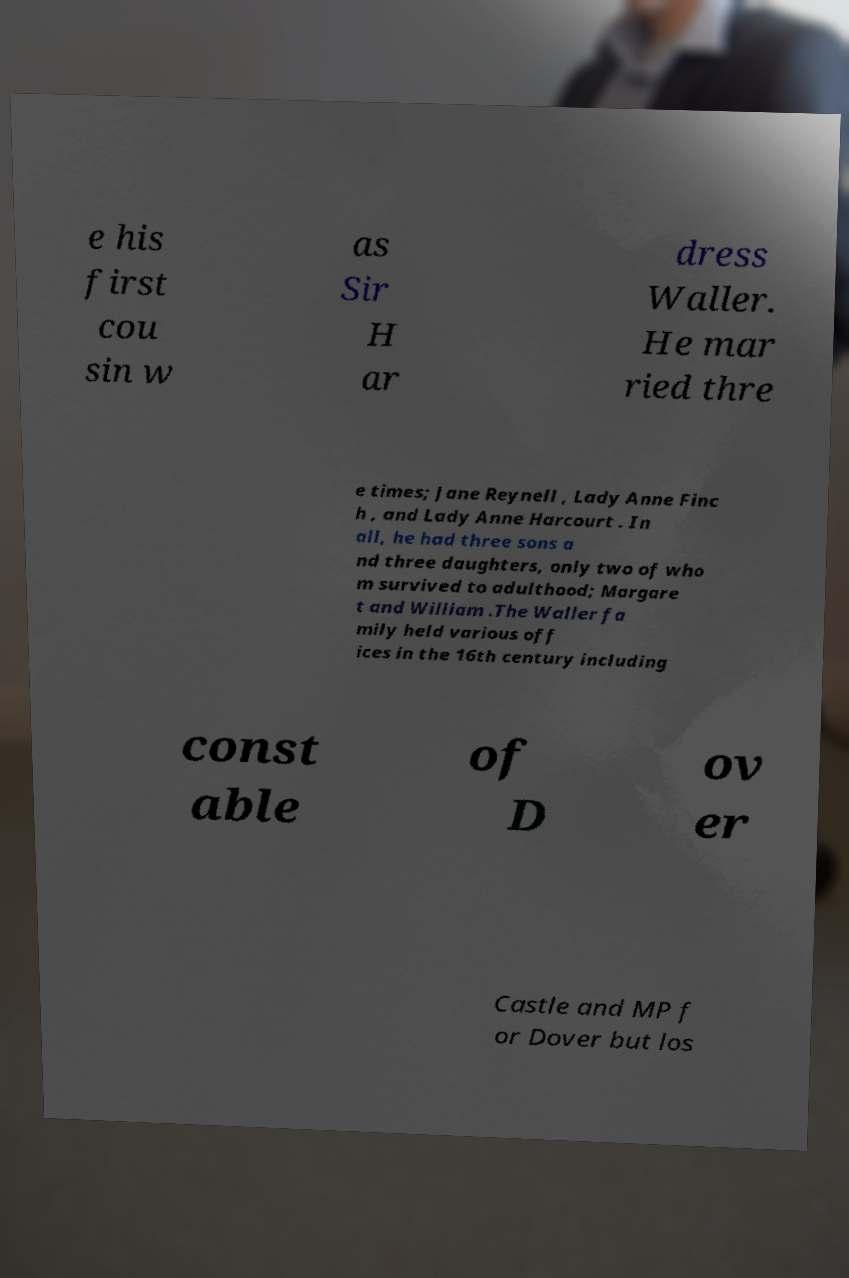Can you accurately transcribe the text from the provided image for me? e his first cou sin w as Sir H ar dress Waller. He mar ried thre e times; Jane Reynell , Lady Anne Finc h , and Lady Anne Harcourt . In all, he had three sons a nd three daughters, only two of who m survived to adulthood; Margare t and William .The Waller fa mily held various off ices in the 16th century including const able of D ov er Castle and MP f or Dover but los 